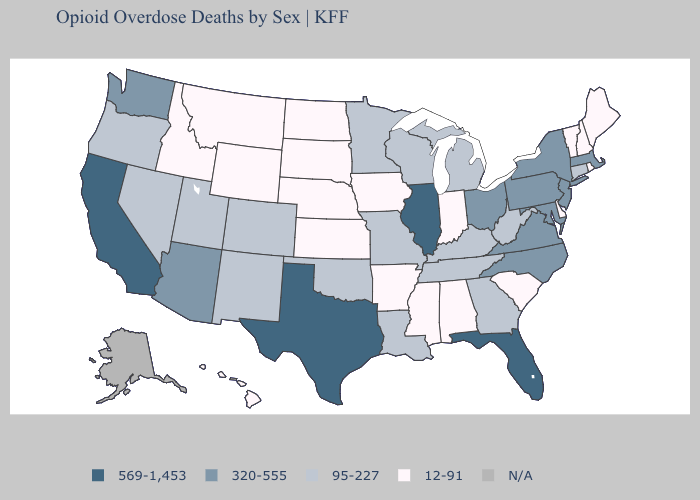Name the states that have a value in the range 320-555?
Quick response, please. Arizona, Maryland, Massachusetts, New Jersey, New York, North Carolina, Ohio, Pennsylvania, Virginia, Washington. Is the legend a continuous bar?
Quick response, please. No. What is the value of South Carolina?
Answer briefly. 12-91. What is the highest value in the USA?
Keep it brief. 569-1,453. What is the value of Maine?
Keep it brief. 12-91. Name the states that have a value in the range N/A?
Answer briefly. Alaska. What is the highest value in states that border Georgia?
Keep it brief. 569-1,453. Which states have the lowest value in the South?
Give a very brief answer. Alabama, Arkansas, Delaware, Mississippi, South Carolina. What is the value of Missouri?
Quick response, please. 95-227. Among the states that border Arkansas , which have the highest value?
Keep it brief. Texas. What is the lowest value in states that border Massachusetts?
Concise answer only. 12-91. 